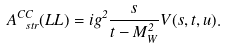<formula> <loc_0><loc_0><loc_500><loc_500>A ^ { C C } _ { \ s t r } ( L L ) = i g ^ { 2 } \frac { s } { t - M _ { W } ^ { 2 } } V ( s , t , u ) .</formula> 